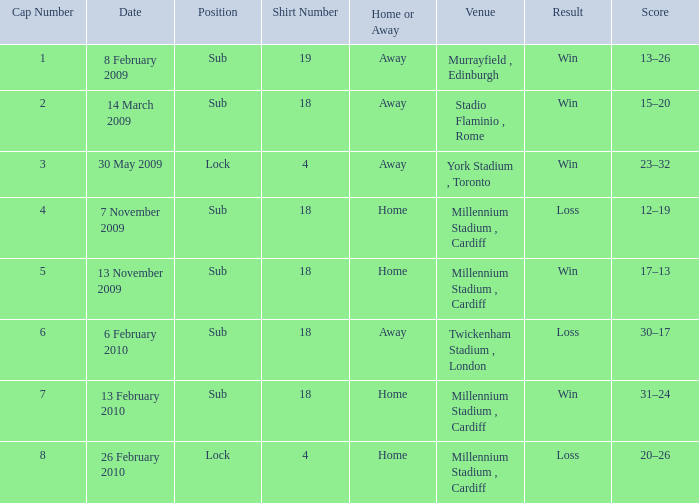Can you tell me the Score that has the Result of win, and the Date of 13 november 2009? 17–13. 